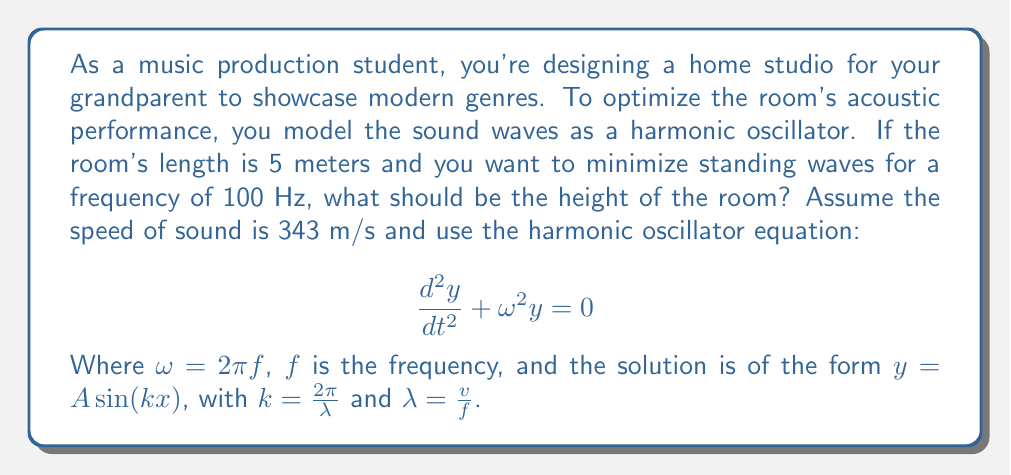Show me your answer to this math problem. To solve this problem, we'll follow these steps:

1) First, we need to understand that standing waves occur when the room dimension is a multiple of half the wavelength. To minimize standing waves, we want the room dimension to be an odd multiple of quarter wavelengths.

2) Calculate the wavelength $\lambda$ for a 100 Hz tone:
   $\lambda = \frac{v}{f} = \frac{343 \text{ m/s}}{100 \text{ Hz}} = 3.43 \text{ m}$

3) For the height, we want:
   $\text{height} = (2n+1)\frac{\lambda}{4}$, where $n$ is a non-negative integer

4) We need to choose $n$ such that the height is practical for a room. Let's try $n = 1$:
   $\text{height} = (2(1)+1)\frac{3.43}{4} = 3 \cdot 0.8575 = 2.5725 \text{ m}$

5) This is a reasonable height for a room, so we'll use this value.

6) To verify, we can use the harmonic oscillator equation. The general solution is:
   $y(x,t) = A\sin(kx)\cos(\omega t)$

   Where $k = \frac{2\pi}{\lambda} = \frac{2\pi}{3.43} \approx 1.83 \text{ m}^{-1}$

7) For a standing wave, we need $y(0,t) = y(L,t) = 0$ for all $t$, where $L$ is the room height.
   This is satisfied when $kL = (2n+1)\frac{\pi}{2}$

8) Checking our solution:
   $kL = 1.83 \cdot 2.5725 \approx 4.71 \approx \frac{3\pi}{2}$

This confirms that our calculated height creates the desired standing wave pattern, minimizing interference for the 100 Hz frequency.
Answer: The optimal height of the room should be approximately 2.57 meters. 